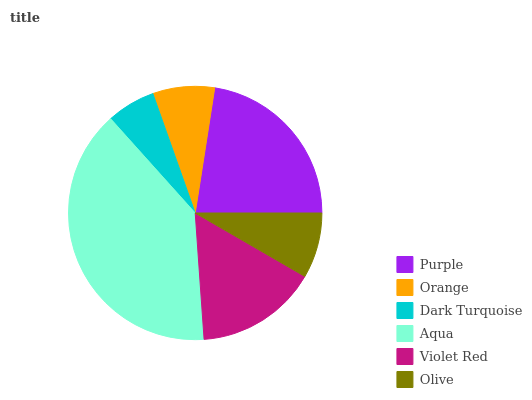Is Dark Turquoise the minimum?
Answer yes or no. Yes. Is Aqua the maximum?
Answer yes or no. Yes. Is Orange the minimum?
Answer yes or no. No. Is Orange the maximum?
Answer yes or no. No. Is Purple greater than Orange?
Answer yes or no. Yes. Is Orange less than Purple?
Answer yes or no. Yes. Is Orange greater than Purple?
Answer yes or no. No. Is Purple less than Orange?
Answer yes or no. No. Is Violet Red the high median?
Answer yes or no. Yes. Is Olive the low median?
Answer yes or no. Yes. Is Purple the high median?
Answer yes or no. No. Is Aqua the low median?
Answer yes or no. No. 